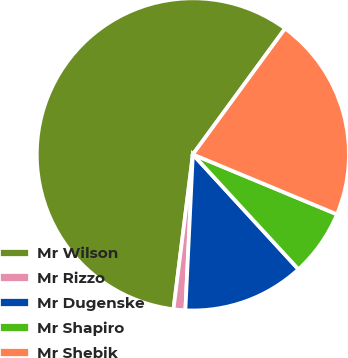Convert chart to OTSL. <chart><loc_0><loc_0><loc_500><loc_500><pie_chart><fcel>Mr Wilson<fcel>Mr Rizzo<fcel>Mr Dugenske<fcel>Mr Shapiro<fcel>Mr Shebik<nl><fcel>58.08%<fcel>1.22%<fcel>12.59%<fcel>6.9%<fcel>21.21%<nl></chart> 